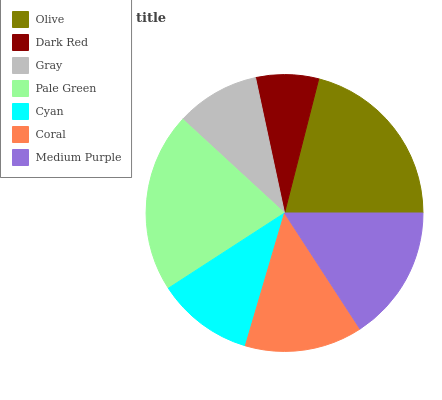Is Dark Red the minimum?
Answer yes or no. Yes. Is Olive the maximum?
Answer yes or no. Yes. Is Gray the minimum?
Answer yes or no. No. Is Gray the maximum?
Answer yes or no. No. Is Gray greater than Dark Red?
Answer yes or no. Yes. Is Dark Red less than Gray?
Answer yes or no. Yes. Is Dark Red greater than Gray?
Answer yes or no. No. Is Gray less than Dark Red?
Answer yes or no. No. Is Coral the high median?
Answer yes or no. Yes. Is Coral the low median?
Answer yes or no. Yes. Is Gray the high median?
Answer yes or no. No. Is Cyan the low median?
Answer yes or no. No. 